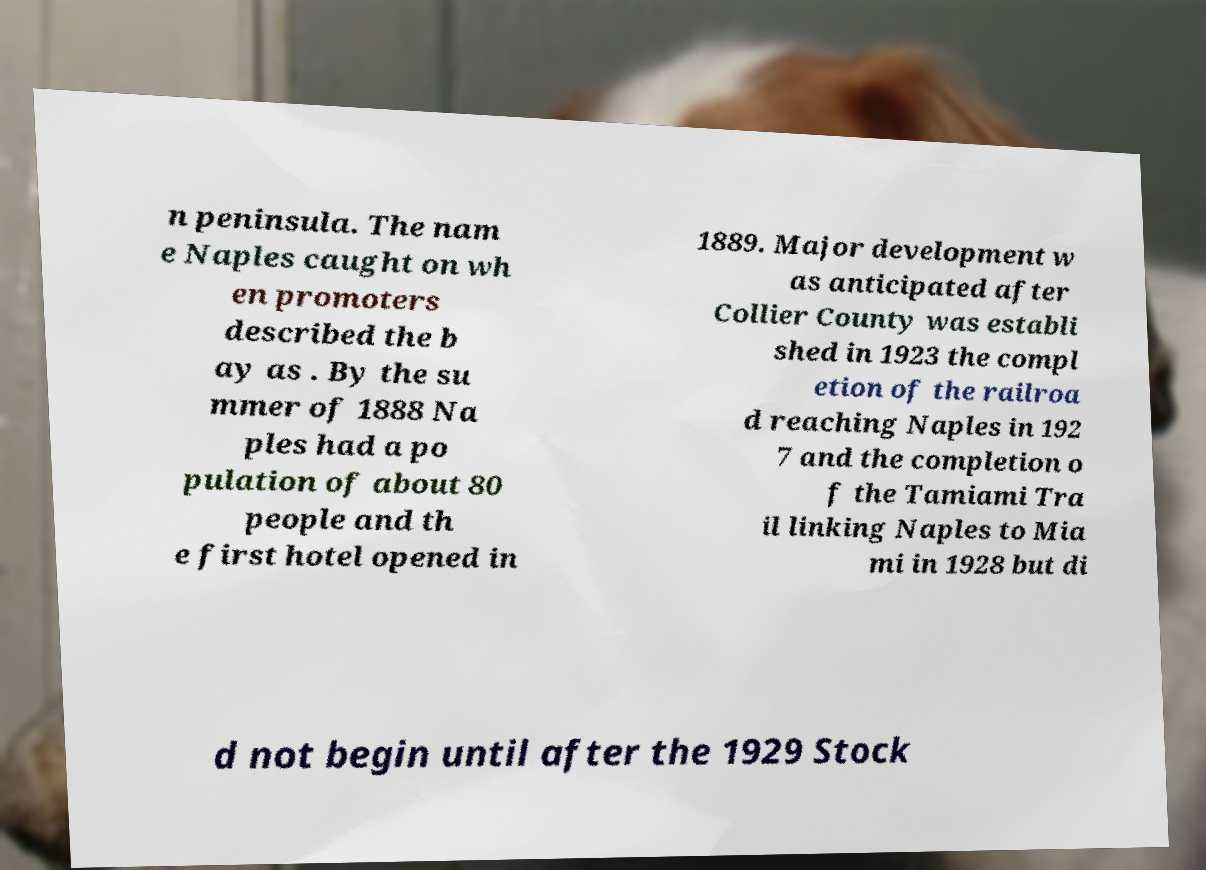What messages or text are displayed in this image? I need them in a readable, typed format. n peninsula. The nam e Naples caught on wh en promoters described the b ay as . By the su mmer of 1888 Na ples had a po pulation of about 80 people and th e first hotel opened in 1889. Major development w as anticipated after Collier County was establi shed in 1923 the compl etion of the railroa d reaching Naples in 192 7 and the completion o f the Tamiami Tra il linking Naples to Mia mi in 1928 but di d not begin until after the 1929 Stock 